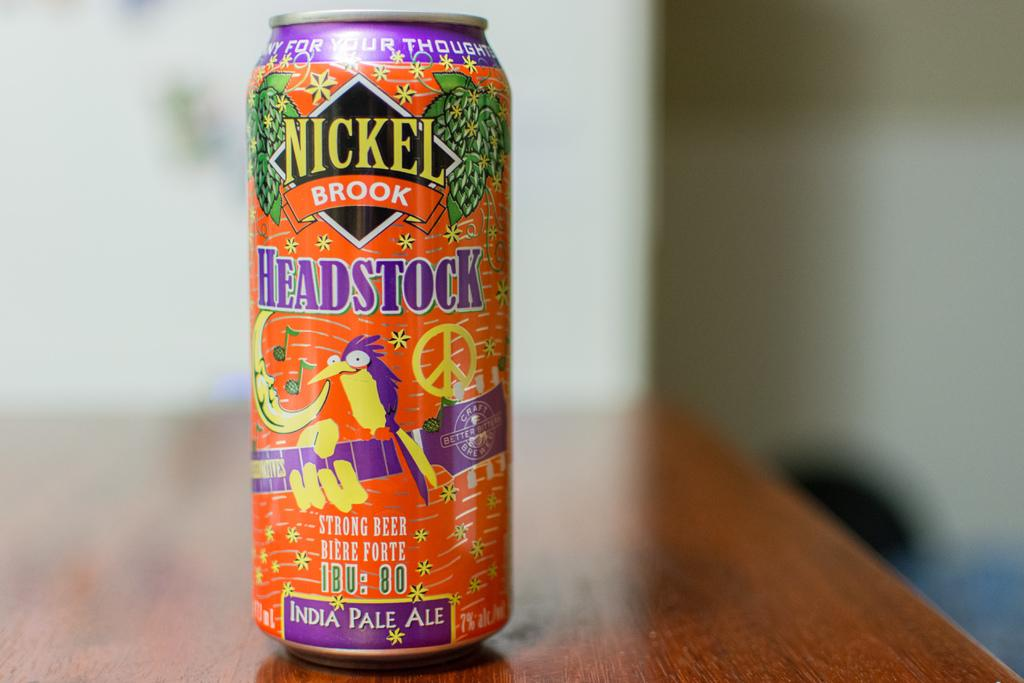<image>
Present a compact description of the photo's key features. A bottle of Headstock pale ale has a bright orange can with purple and yellow designs. 